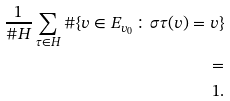Convert formula to latex. <formula><loc_0><loc_0><loc_500><loc_500>\frac { 1 } { \# H } \sum _ { \tau \in H } \# \{ v \in E _ { v _ { 0 } } \colon \sigma \tau ( v ) = v \} \\ = \\ 1 .</formula> 